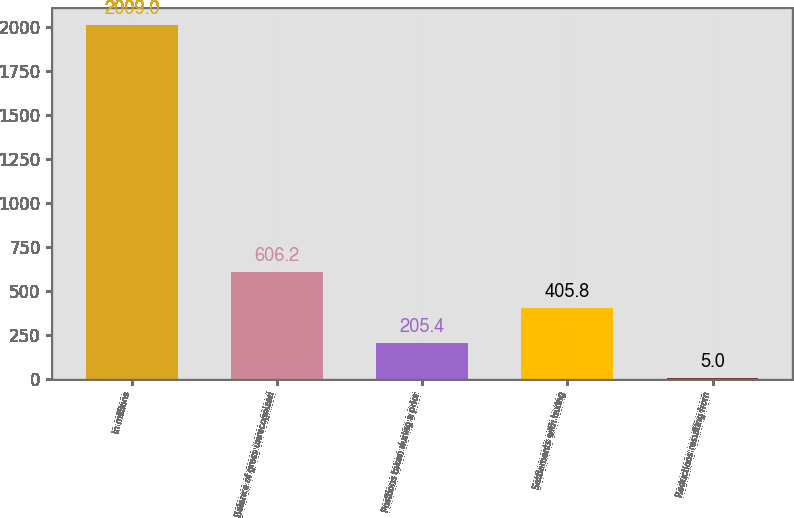<chart> <loc_0><loc_0><loc_500><loc_500><bar_chart><fcel>In millions<fcel>Balance of gross unrecognized<fcel>Positions taken during a prior<fcel>Settlements with taxing<fcel>Reductions resulting from<nl><fcel>2009<fcel>606.2<fcel>205.4<fcel>405.8<fcel>5<nl></chart> 